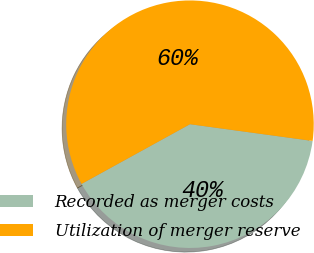Convert chart to OTSL. <chart><loc_0><loc_0><loc_500><loc_500><pie_chart><fcel>Recorded as merger costs<fcel>Utilization of merger reserve<nl><fcel>39.83%<fcel>60.17%<nl></chart> 